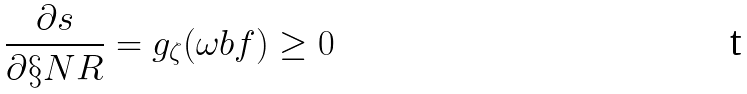Convert formula to latex. <formula><loc_0><loc_0><loc_500><loc_500>\frac { \partial s } { \partial \S N R } = g _ { \zeta } ( \omega b f ) \geq 0</formula> 